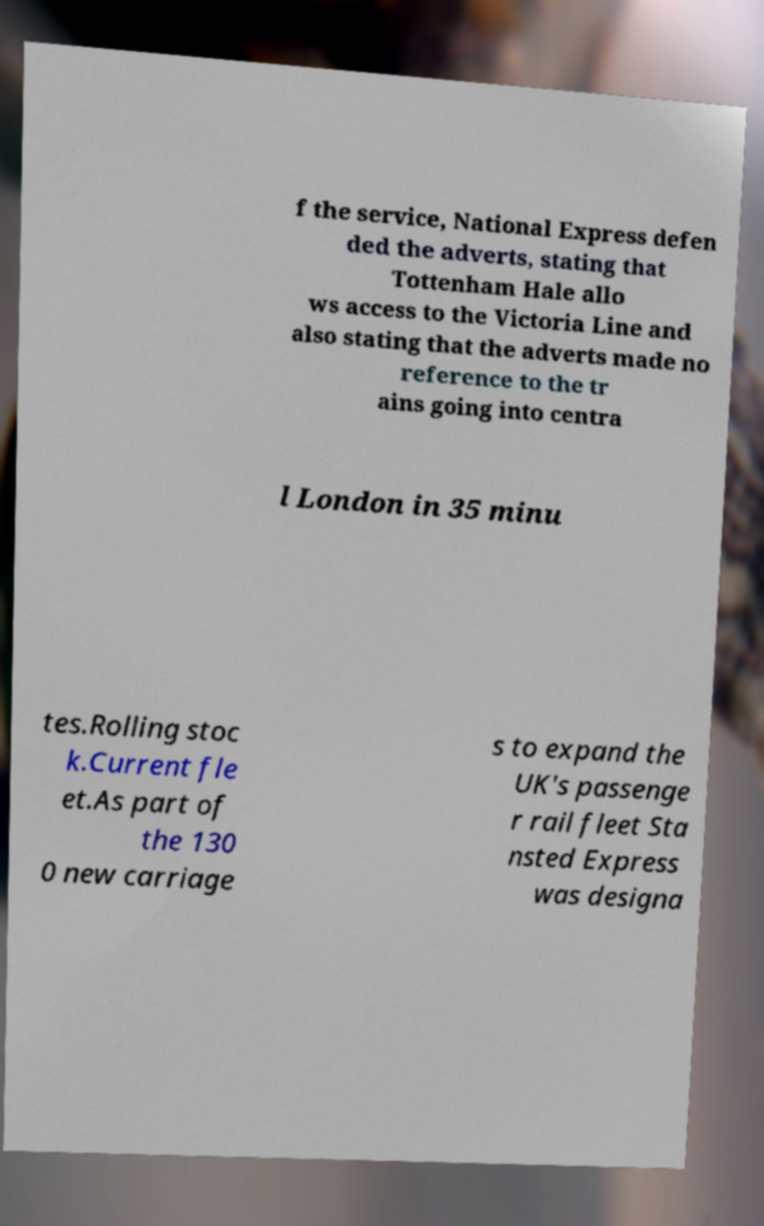Can you accurately transcribe the text from the provided image for me? f the service, National Express defen ded the adverts, stating that Tottenham Hale allo ws access to the Victoria Line and also stating that the adverts made no reference to the tr ains going into centra l London in 35 minu tes.Rolling stoc k.Current fle et.As part of the 130 0 new carriage s to expand the UK's passenge r rail fleet Sta nsted Express was designa 